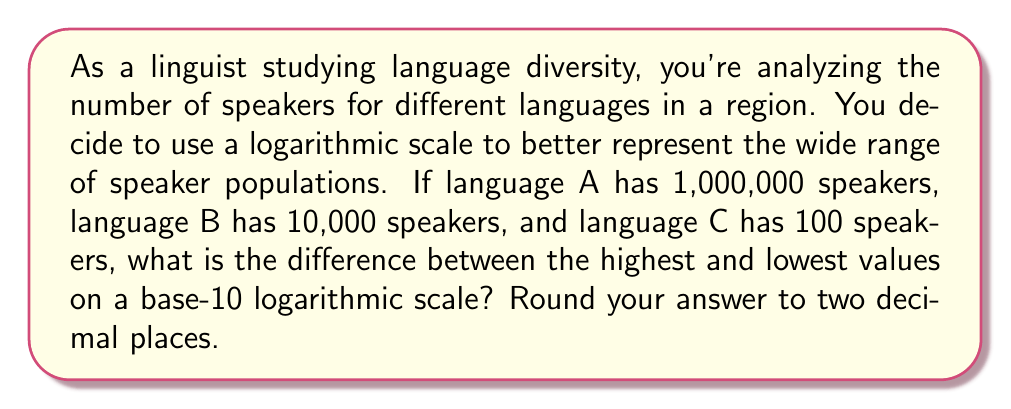Give your solution to this math problem. To solve this problem, we need to follow these steps:

1. Convert each language's speaker count to its logarithmic value using base 10.

2. Find the highest and lowest logarithmic values.

3. Calculate the difference between the highest and lowest values.

Step 1: Converting to logarithmic values

For language A: $\log_{10}(1,000,000) = 6$
For language B: $\log_{10}(10,000) = 4$
For language C: $\log_{10}(100) = 2$

Step 2: Identifying highest and lowest values

Highest value: 6 (language A)
Lowest value: 2 (language C)

Step 3: Calculating the difference

Difference = Highest value - Lowest value
           = 6 - 2
           = 4

Therefore, the difference between the highest and lowest values on the base-10 logarithmic scale is 4.

This result shows that on a logarithmic scale, the difference between languages with vastly different numbers of speakers (1,000,000 vs. 100) can be represented by a more manageable range (6 vs. 2 on the log scale). This makes it easier to visualize and compare language diversity across a wide range of speaker populations.
Answer: 4 